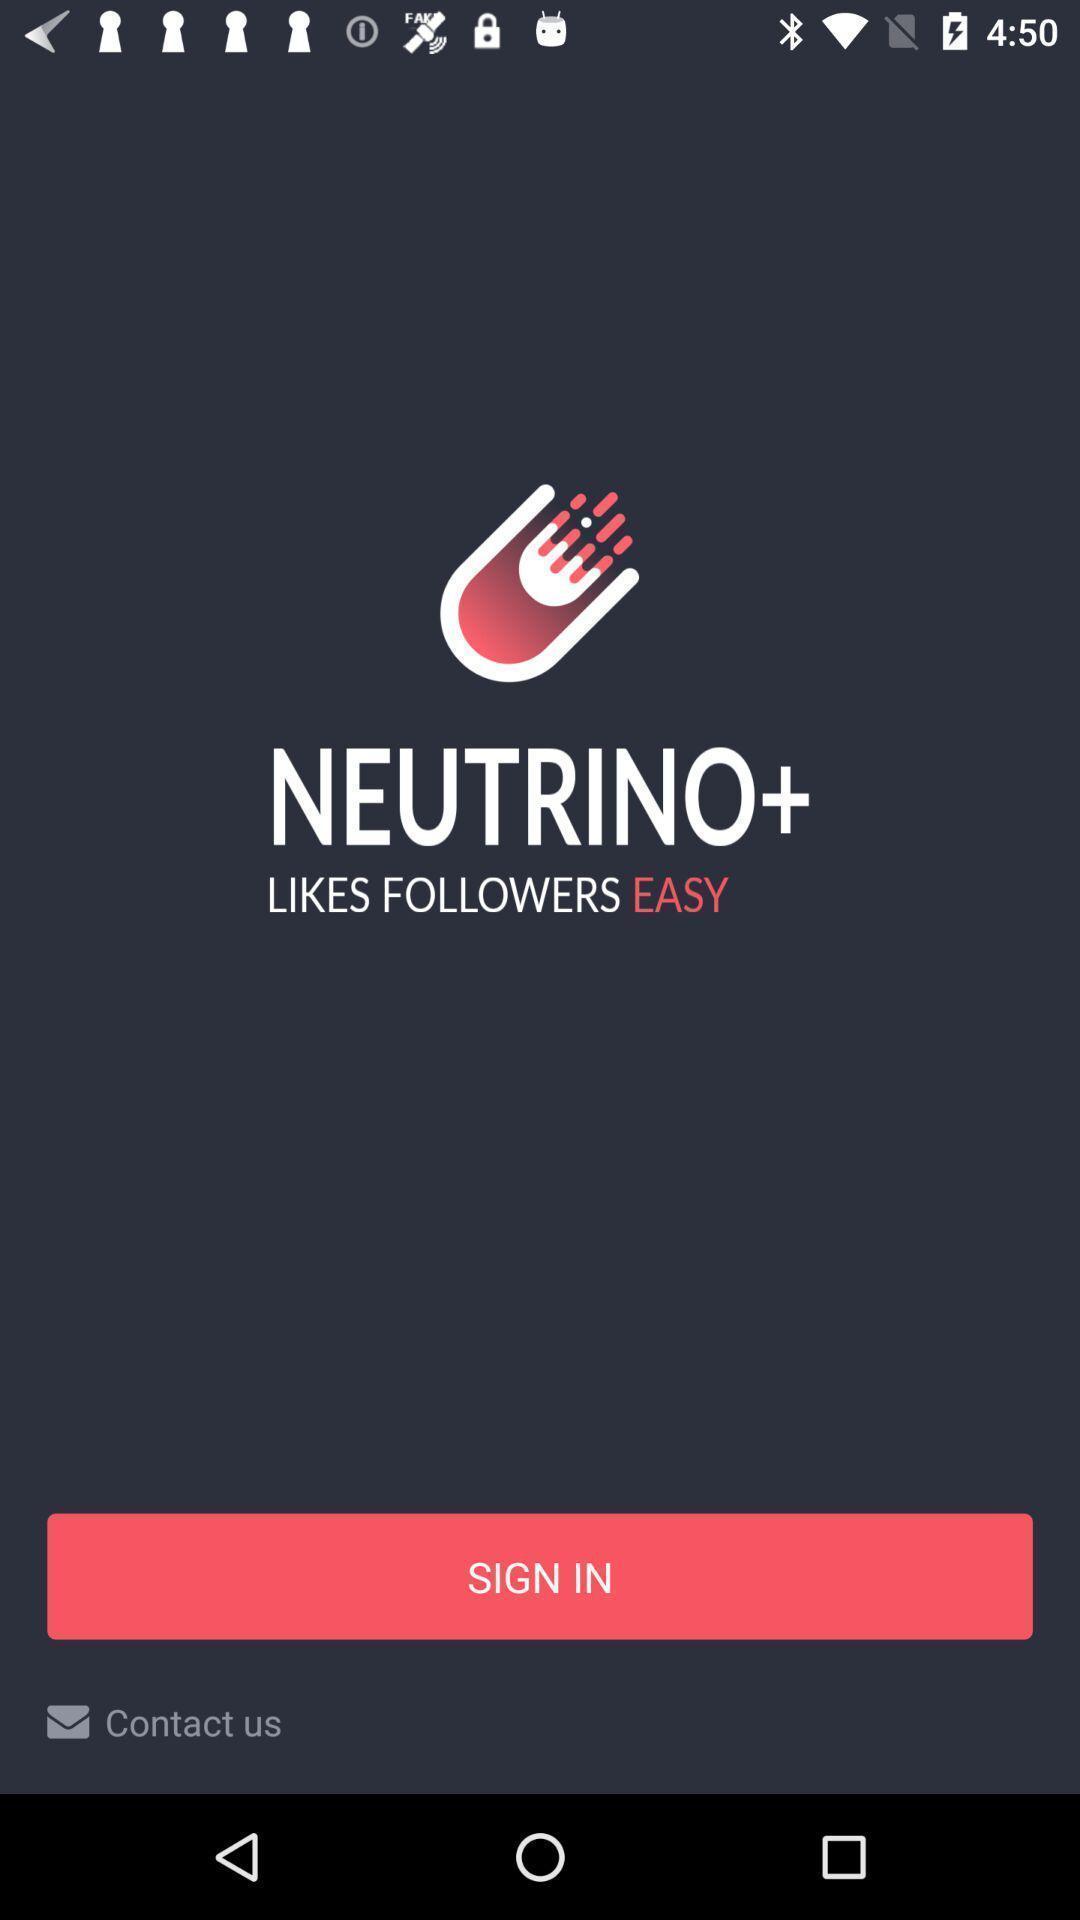Explain what's happening in this screen capture. Sign-in page. 